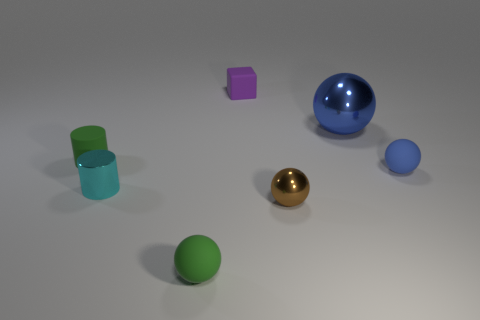Subtract 1 balls. How many balls are left? 3 Add 2 cyan metallic cylinders. How many objects exist? 9 Subtract all blocks. How many objects are left? 6 Add 6 small metal objects. How many small metal objects are left? 8 Add 4 blue matte things. How many blue matte things exist? 5 Subtract 0 brown cubes. How many objects are left? 7 Subtract all tiny brown matte spheres. Subtract all small spheres. How many objects are left? 4 